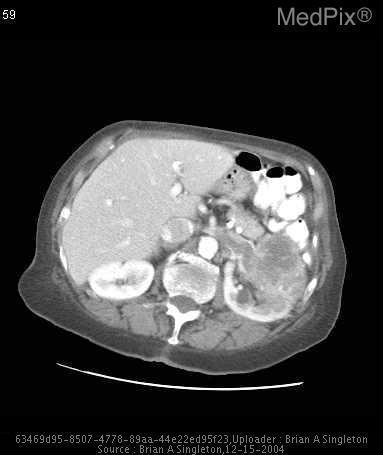There is a large enhancing mass growing from what organ in this ct scan?
Be succinct. The left kidney. Can the liver be seen in this image?
Give a very brief answer. Yes. What vessel is seen just anterior to the spine enhancing with contrast?
Concise answer only. The aorta. 